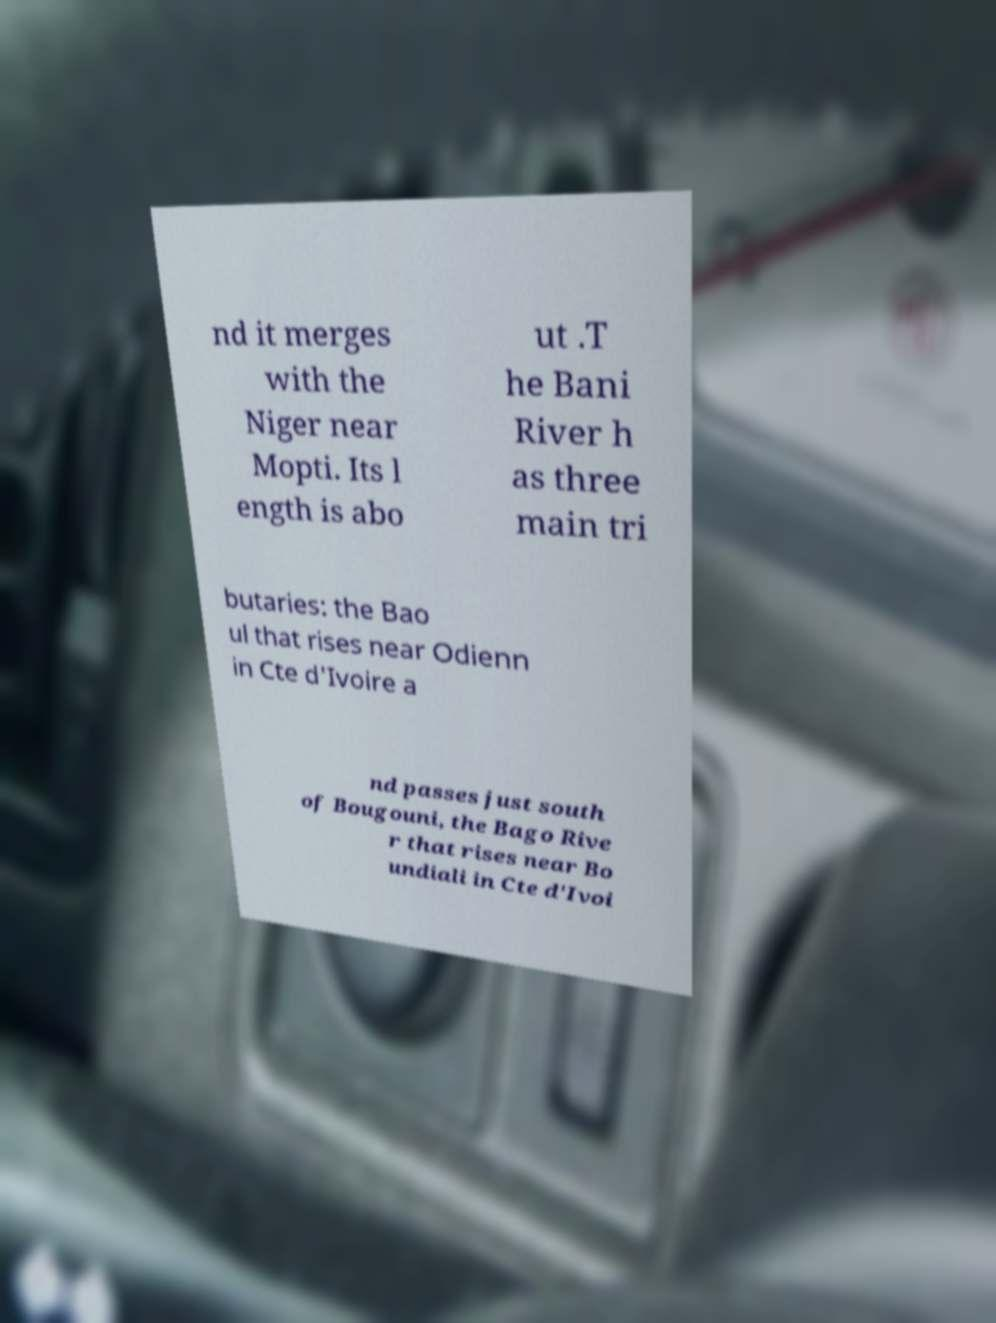Can you read and provide the text displayed in the image?This photo seems to have some interesting text. Can you extract and type it out for me? nd it merges with the Niger near Mopti. Its l ength is abo ut .T he Bani River h as three main tri butaries: the Bao ul that rises near Odienn in Cte d'Ivoire a nd passes just south of Bougouni, the Bago Rive r that rises near Bo undiali in Cte d'Ivoi 